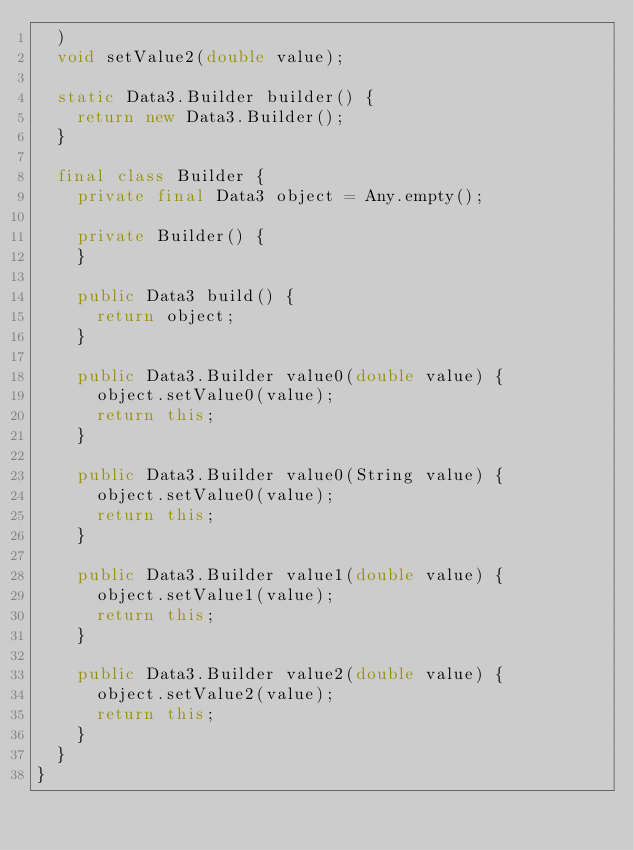Convert code to text. <code><loc_0><loc_0><loc_500><loc_500><_Java_>  )
  void setValue2(double value);

  static Data3.Builder builder() {
    return new Data3.Builder();
  }

  final class Builder {
    private final Data3 object = Any.empty();

    private Builder() {
    }

    public Data3 build() {
      return object;
    }

    public Data3.Builder value0(double value) {
      object.setValue0(value);
      return this;
    }

    public Data3.Builder value0(String value) {
      object.setValue0(value);
      return this;
    }

    public Data3.Builder value1(double value) {
      object.setValue1(value);
      return this;
    }

    public Data3.Builder value2(double value) {
      object.setValue2(value);
      return this;
    }
  }
}
</code> 